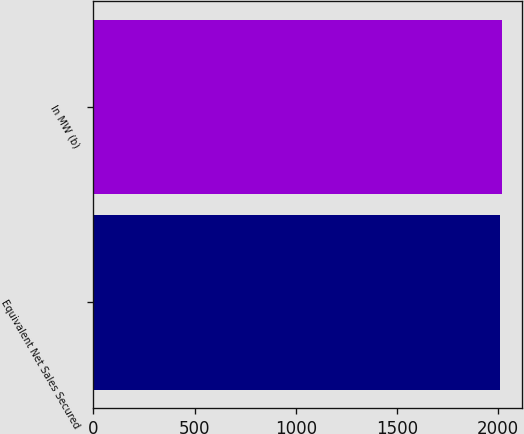<chart> <loc_0><loc_0><loc_500><loc_500><bar_chart><fcel>Equivalent Net Sales Secured<fcel>In MW (b)<nl><fcel>2011<fcel>2019<nl></chart> 